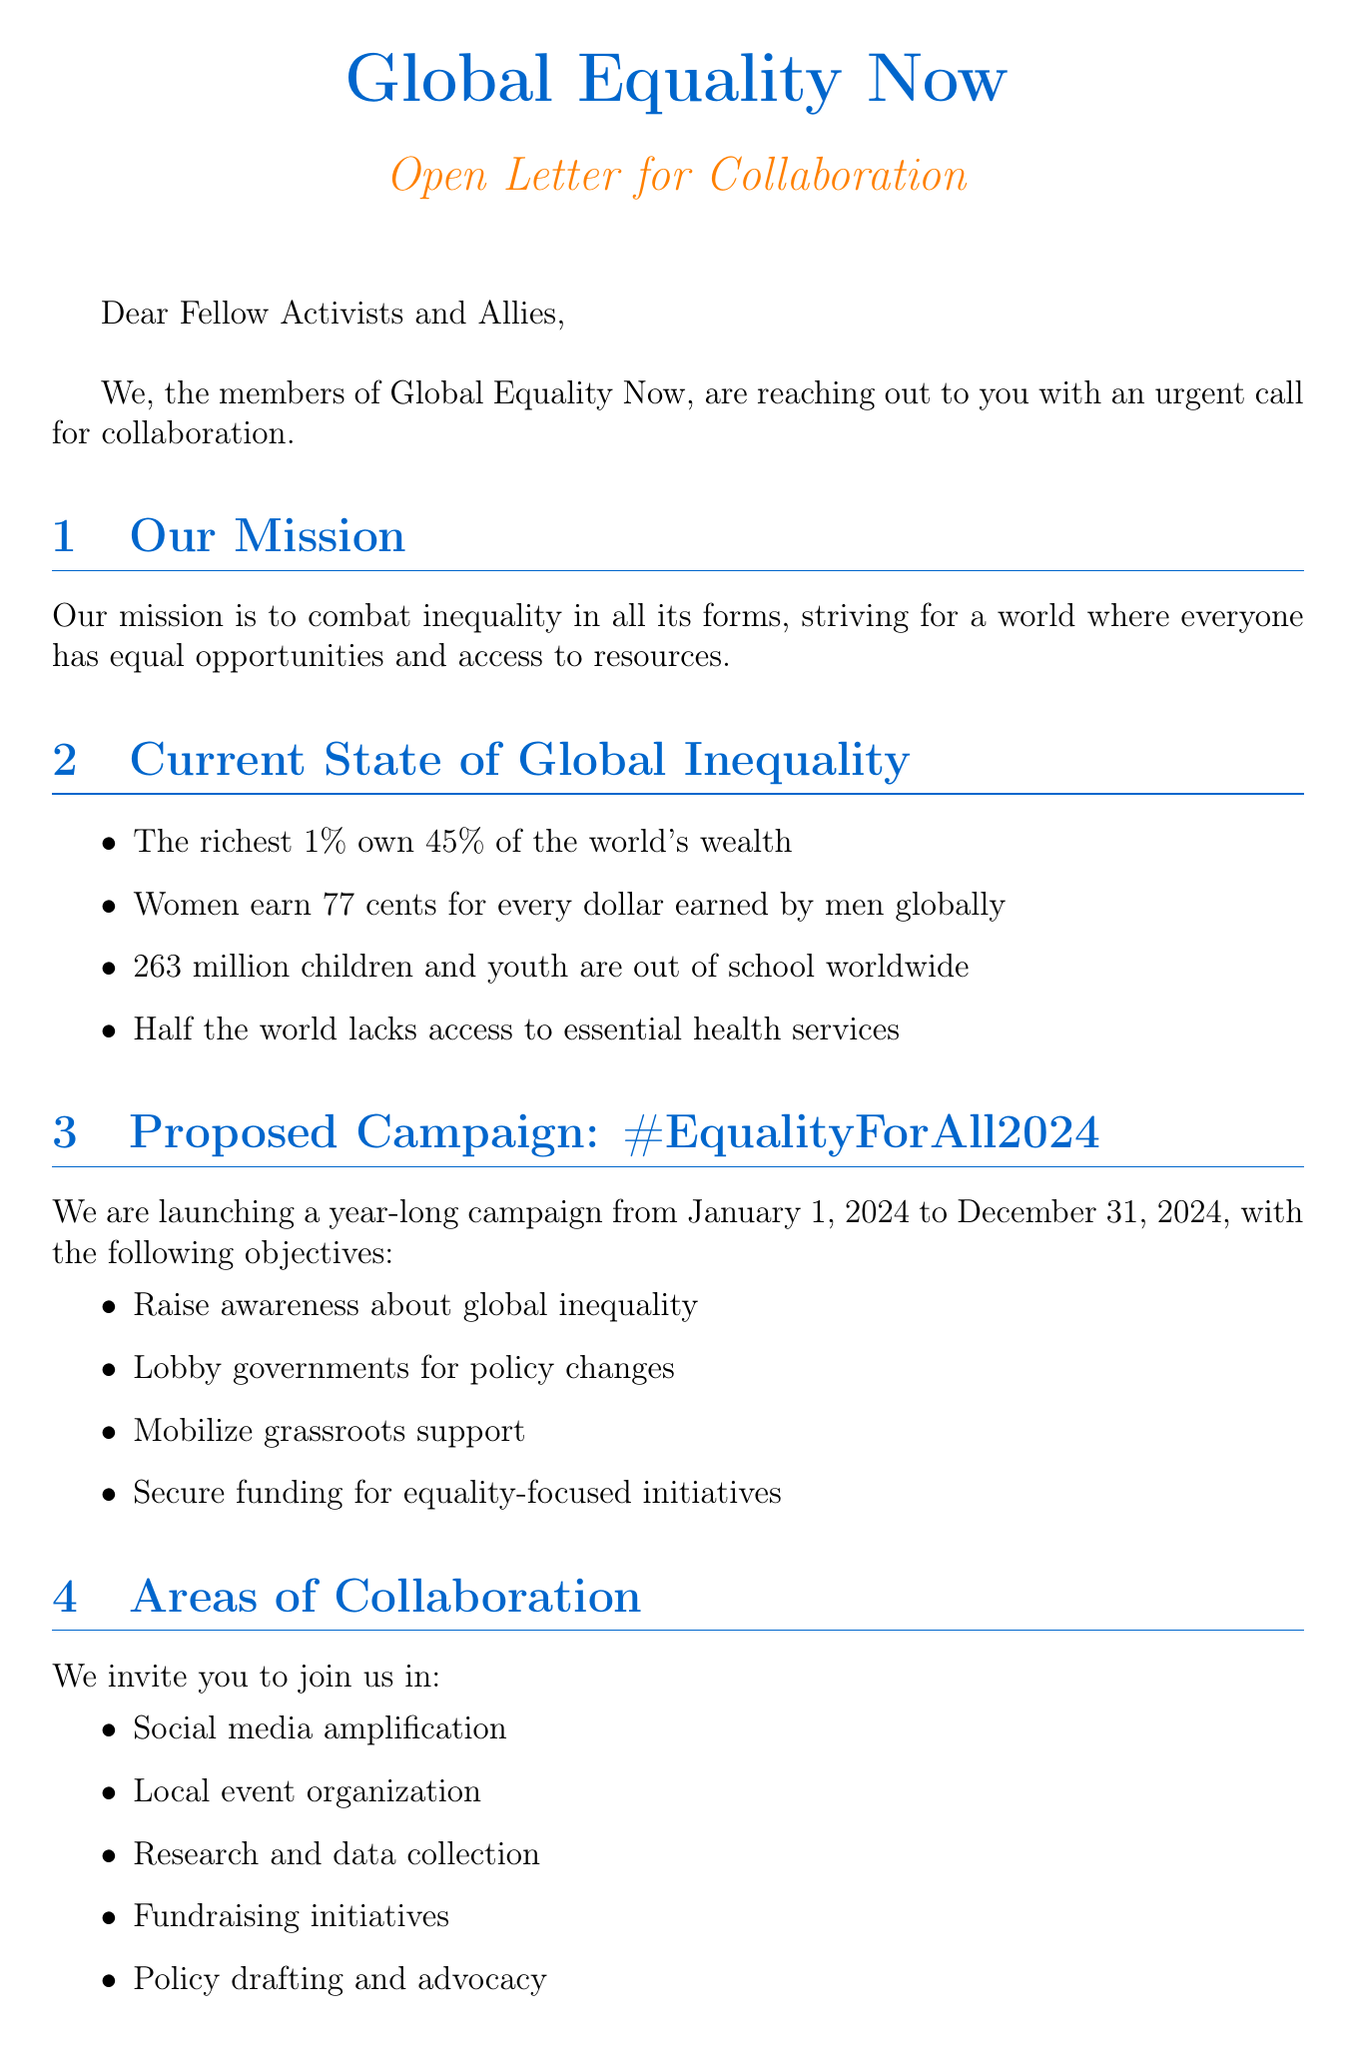What is the name of the campaign? The campaign is titled #EqualityForAll2024, as mentioned in the document.
Answer: #EqualityForAll2024 Who is the Executive Director of the organization? The letter is signed by Maria Rodriguez, who holds the position of Executive Director.
Answer: Maria Rodriguez What percentage of the world's wealth do the richest 1% own? The document states that the richest 1% own 45% of the world's wealth.
Answer: 45% What is the duration of the proposed campaign? The campaign runs from January 1, 2024, to December 31, 2024, as indicated in the document.
Answer: January 1, 2024 - December 31, 2024 How many children and youth are out of school worldwide? The document states that 263 million children and youth are out of school worldwide.
Answer: 263 million What is one of the expected outcomes of the campaign? The document lists multiple expected outcomes, one of which is to reduce wealth inequality.
Answer: Reduce wealth inequality What area of collaboration involves gathering information? Research and data collection is mentioned as a collaborative area focused on gathering information.
Answer: Research and data collection Who are some prominent supporters of the campaign? The document lists several prominent supporters, including Malala Yousafzai and Ban Ki-moon.
Answer: Malala Yousafzai What is the call to action in the infographic? The infographic ends with a clear call to action encouraging participation in the campaign.
Answer: Join us in the fight for a more equal world. #EqualityForAll2024 